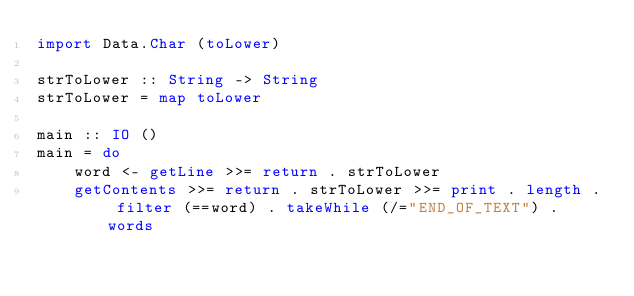Convert code to text. <code><loc_0><loc_0><loc_500><loc_500><_Haskell_>import Data.Char (toLower)

strToLower :: String -> String
strToLower = map toLower

main :: IO ()
main = do
    word <- getLine >>= return . strToLower
    getContents >>= return . strToLower >>= print . length . filter (==word) . takeWhile (/="END_OF_TEXT") . words
</code> 